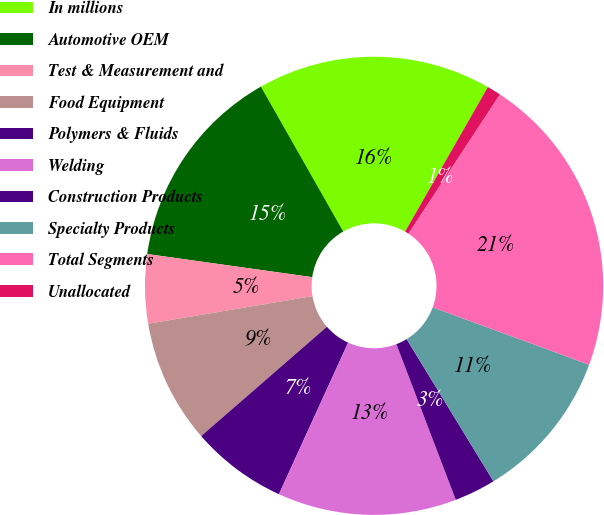Convert chart. <chart><loc_0><loc_0><loc_500><loc_500><pie_chart><fcel>In millions<fcel>Automotive OEM<fcel>Test & Measurement and<fcel>Food Equipment<fcel>Polymers & Fluids<fcel>Welding<fcel>Construction Products<fcel>Specialty Products<fcel>Total Segments<fcel>Unallocated<nl><fcel>16.5%<fcel>14.56%<fcel>4.86%<fcel>8.74%<fcel>6.8%<fcel>12.62%<fcel>2.92%<fcel>10.68%<fcel>21.34%<fcel>0.98%<nl></chart> 